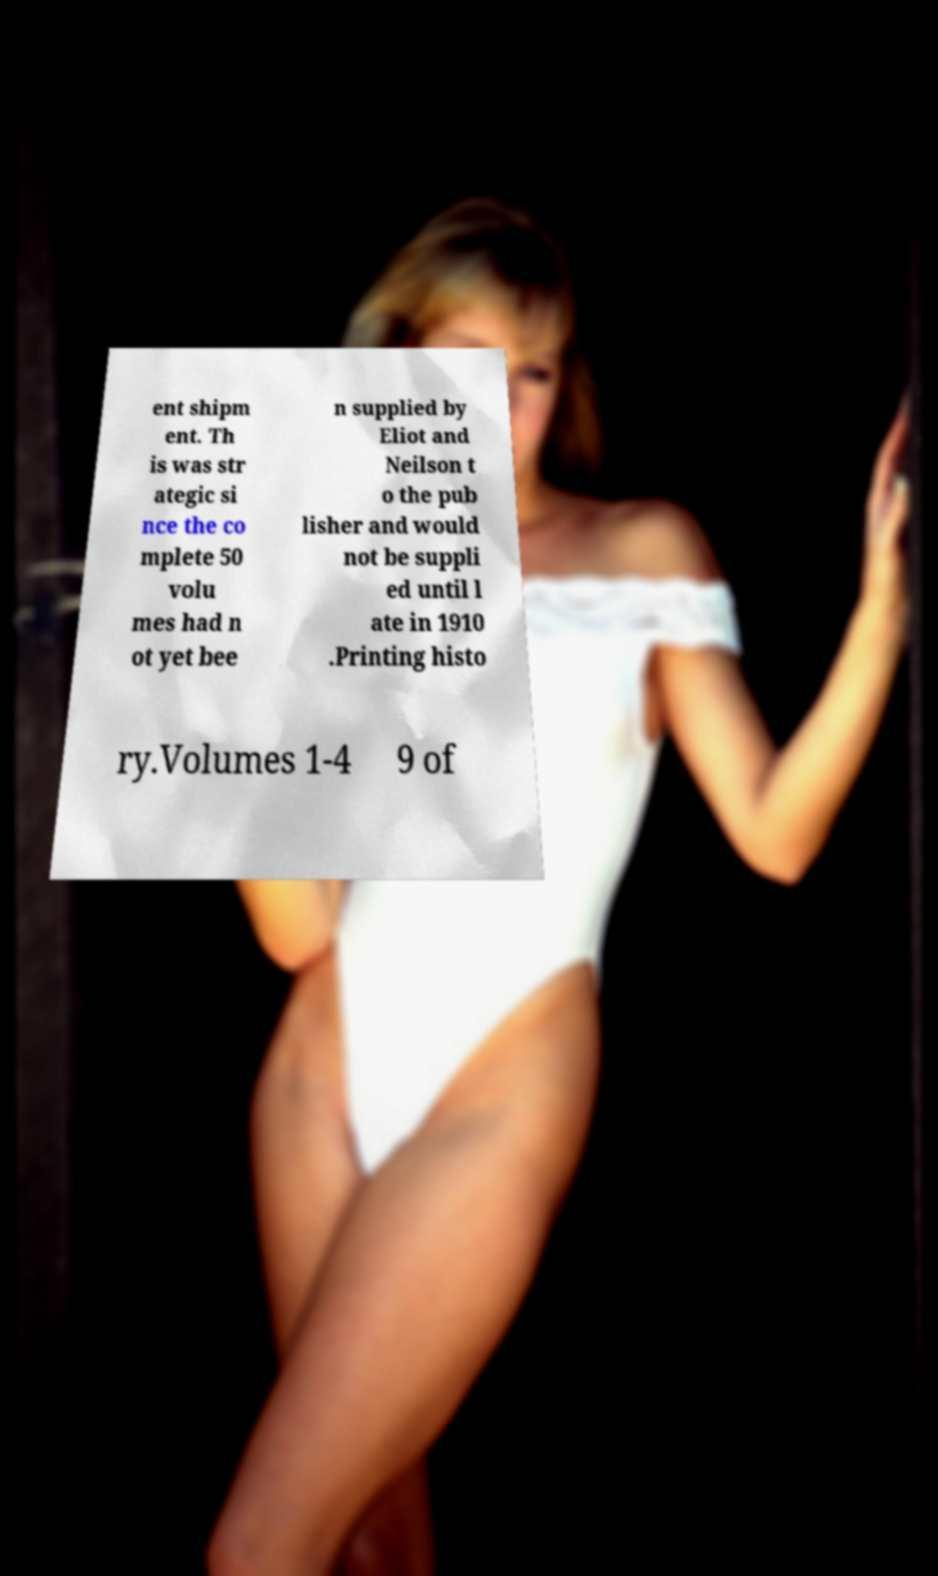I need the written content from this picture converted into text. Can you do that? ent shipm ent. Th is was str ategic si nce the co mplete 50 volu mes had n ot yet bee n supplied by Eliot and Neilson t o the pub lisher and would not be suppli ed until l ate in 1910 .Printing histo ry.Volumes 1-4 9 of 